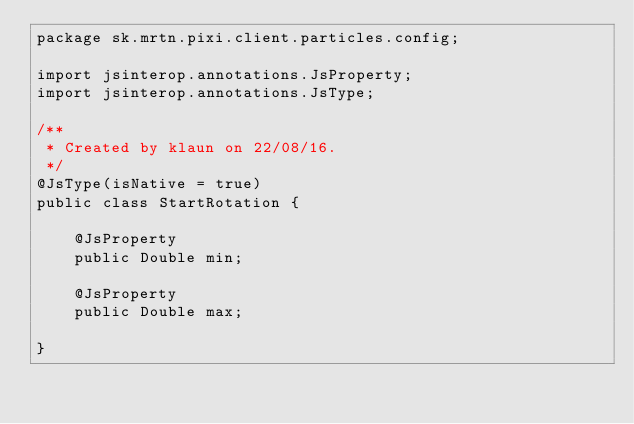Convert code to text. <code><loc_0><loc_0><loc_500><loc_500><_Java_>package sk.mrtn.pixi.client.particles.config;

import jsinterop.annotations.JsProperty;
import jsinterop.annotations.JsType;

/**
 * Created by klaun on 22/08/16.
 */
@JsType(isNative = true)
public class StartRotation {

    @JsProperty
    public Double min;

    @JsProperty
    public Double max;

}
</code> 